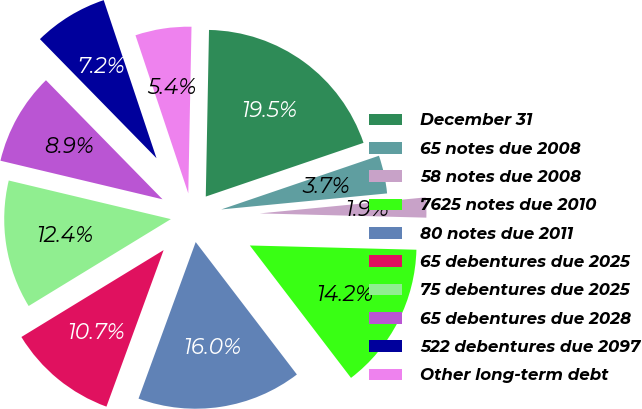Convert chart to OTSL. <chart><loc_0><loc_0><loc_500><loc_500><pie_chart><fcel>December 31<fcel>65 notes due 2008<fcel>58 notes due 2008<fcel>7625 notes due 2010<fcel>80 notes due 2011<fcel>65 debentures due 2025<fcel>75 debentures due 2025<fcel>65 debentures due 2028<fcel>522 debentures due 2097<fcel>Other long-term debt<nl><fcel>19.47%<fcel>3.69%<fcel>1.94%<fcel>14.21%<fcel>15.96%<fcel>10.7%<fcel>12.45%<fcel>8.95%<fcel>7.2%<fcel>5.44%<nl></chart> 